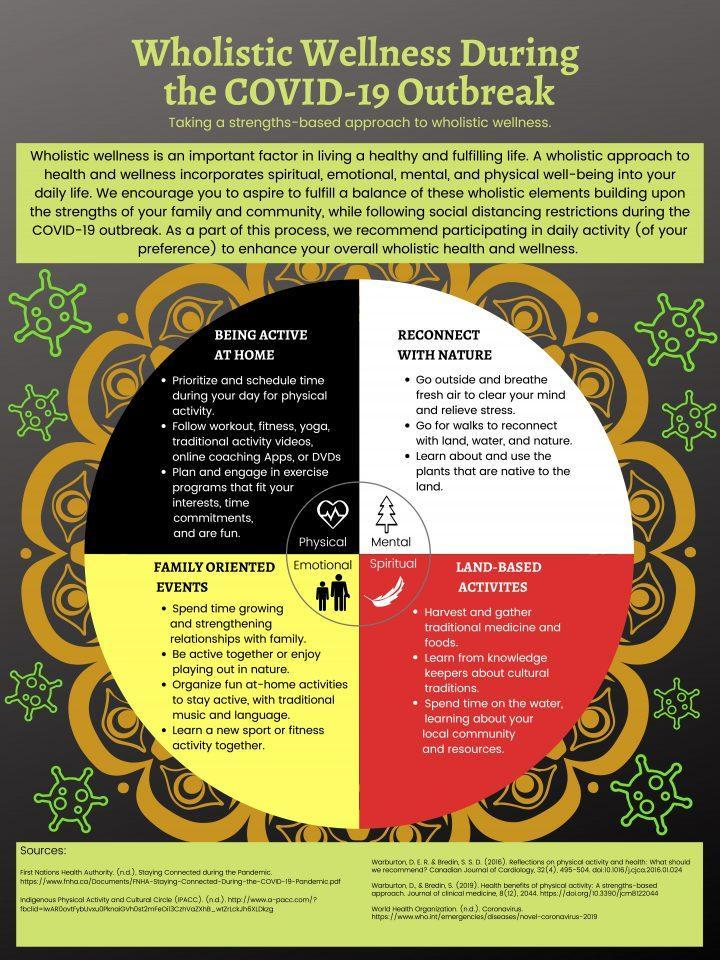According to Wholistic view how one should choose the exercise that suits them?
Answer the question with a short phrase. that fit your interests, time commitments, and are fun According to Wholistic view what one should do to forget everything and come out of stress? Go outside and breathe fresh air According to Wholistic view what you should do to reconnect with nature? go for walks How many points are listed under the heading "Land Based Activities"? 3 What is the fourth point mentioned under "Family oriented Events"? Learn a new sport or fitness activity together 